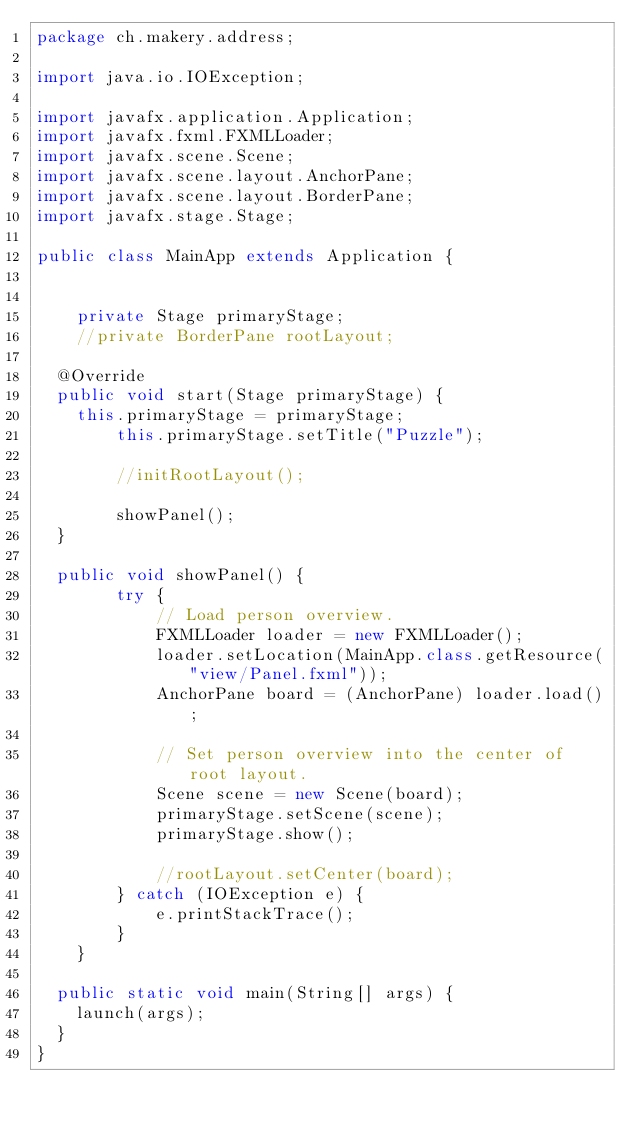Convert code to text. <code><loc_0><loc_0><loc_500><loc_500><_Java_>package ch.makery.address;

import java.io.IOException;

import javafx.application.Application;
import javafx.fxml.FXMLLoader;
import javafx.scene.Scene;
import javafx.scene.layout.AnchorPane;
import javafx.scene.layout.BorderPane;
import javafx.stage.Stage;

public class MainApp extends Application {


    private Stage primaryStage;
    //private BorderPane rootLayout;

	@Override
	public void start(Stage primaryStage) {
		this.primaryStage = primaryStage;
        this.primaryStage.setTitle("Puzzle");

        //initRootLayout();

        showPanel();
	}
	
	public void showPanel() {
        try {
            // Load person overview.
            FXMLLoader loader = new FXMLLoader();
            loader.setLocation(MainApp.class.getResource("view/Panel.fxml"));
            AnchorPane board = (AnchorPane) loader.load();

            // Set person overview into the center of root layout.
            Scene scene = new Scene(board);
            primaryStage.setScene(scene);
            primaryStage.show();
            
            //rootLayout.setCenter(board);
        } catch (IOException e) {
            e.printStackTrace();
        }
    }

	public static void main(String[] args) {
		launch(args);
	}
}
</code> 